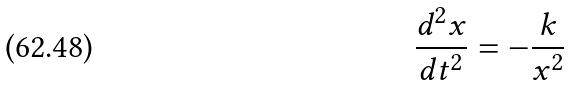Convert formula to latex. <formula><loc_0><loc_0><loc_500><loc_500>\frac { d ^ { 2 } x } { d t ^ { 2 } } = - \frac { k } { x ^ { 2 } }</formula> 